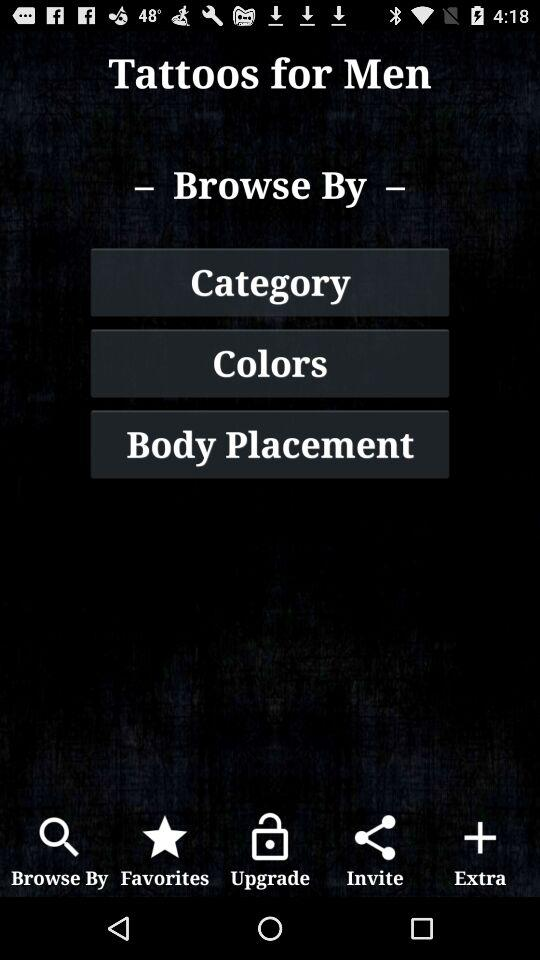What are the options for browsing? The options for browsing are "Category", "Colors" and "Body Placement". 